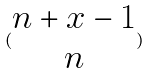<formula> <loc_0><loc_0><loc_500><loc_500>( \begin{matrix} n + x - 1 \\ n \end{matrix} )</formula> 